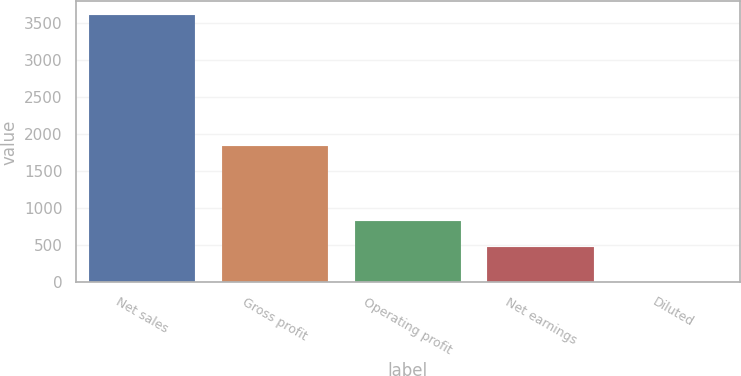<chart> <loc_0><loc_0><loc_500><loc_500><bar_chart><fcel>Net sales<fcel>Gross profit<fcel>Operating profit<fcel>Net earnings<fcel>Diluted<nl><fcel>3609.3<fcel>1840.5<fcel>834.76<fcel>473.9<fcel>0.69<nl></chart> 